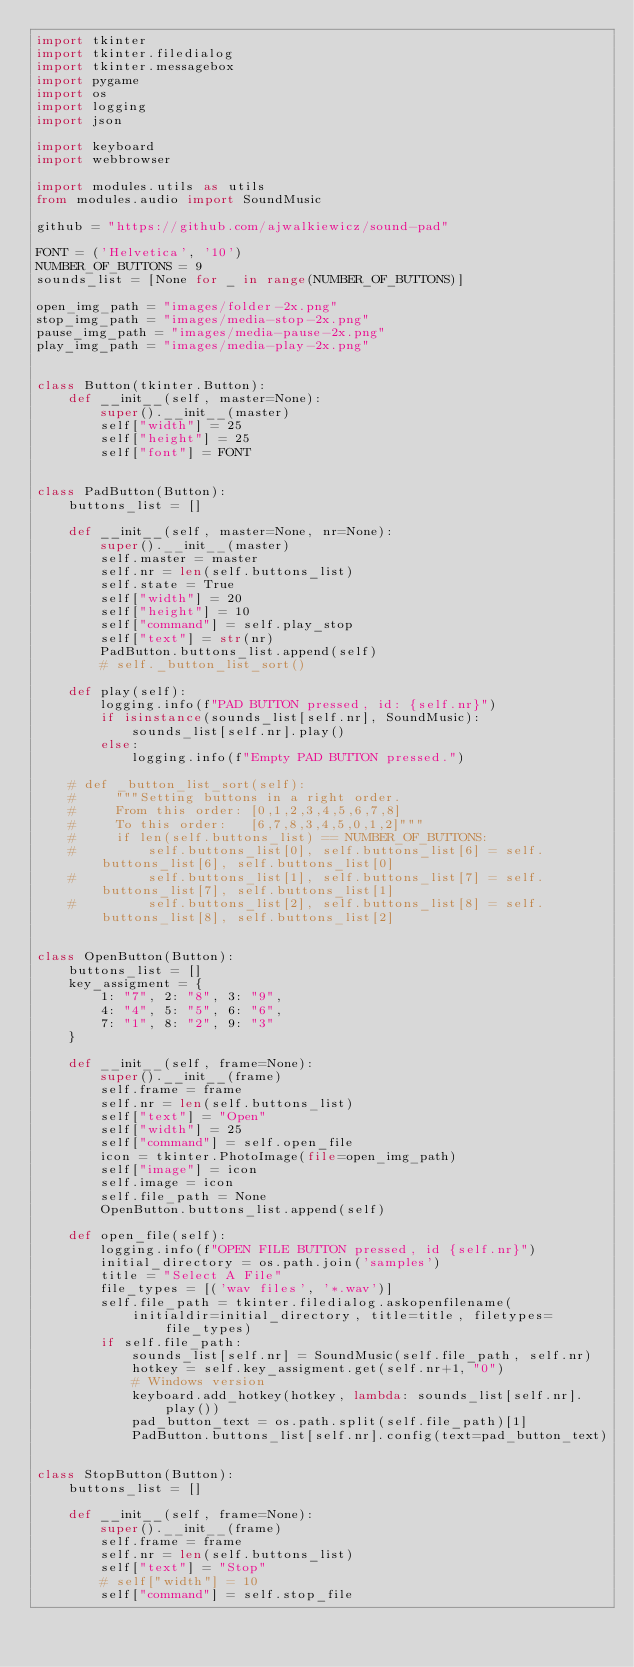<code> <loc_0><loc_0><loc_500><loc_500><_Python_>import tkinter
import tkinter.filedialog
import tkinter.messagebox
import pygame
import os
import logging
import json

import keyboard
import webbrowser

import modules.utils as utils
from modules.audio import SoundMusic

github = "https://github.com/ajwalkiewicz/sound-pad"

FONT = ('Helvetica', '10')
NUMBER_OF_BUTTONS = 9
sounds_list = [None for _ in range(NUMBER_OF_BUTTONS)]

open_img_path = "images/folder-2x.png"
stop_img_path = "images/media-stop-2x.png"
pause_img_path = "images/media-pause-2x.png"
play_img_path = "images/media-play-2x.png"


class Button(tkinter.Button):
    def __init__(self, master=None):
        super().__init__(master)
        self["width"] = 25
        self["height"] = 25
        self["font"] = FONT


class PadButton(Button):
    buttons_list = []

    def __init__(self, master=None, nr=None):
        super().__init__(master)
        self.master = master
        self.nr = len(self.buttons_list)
        self.state = True
        self["width"] = 20
        self["height"] = 10
        self["command"] = self.play_stop
        self["text"] = str(nr)
        PadButton.buttons_list.append(self)
        # self._button_list_sort()

    def play(self):
        logging.info(f"PAD BUTTON pressed, id: {self.nr}")
        if isinstance(sounds_list[self.nr], SoundMusic):
            sounds_list[self.nr].play()
        else:
            logging.info(f"Empty PAD BUTTON pressed.")

    # def _button_list_sort(self):
    #     """Setting buttons in a right order.
    #     From this order: [0,1,2,3,4,5,6,7,8]
    #     To this order:   [6,7,8,3,4,5,0,1,2]"""
    #     if len(self.buttons_list) == NUMBER_OF_BUTTONS:
    #         self.buttons_list[0], self.buttons_list[6] = self.buttons_list[6], self.buttons_list[0]
    #         self.buttons_list[1], self.buttons_list[7] = self.buttons_list[7], self.buttons_list[1]
    #         self.buttons_list[2], self.buttons_list[8] = self.buttons_list[8], self.buttons_list[2]


class OpenButton(Button):
    buttons_list = []
    key_assigment = {
        1: "7", 2: "8", 3: "9",
        4: "4", 5: "5", 6: "6",
        7: "1", 8: "2", 9: "3"
    }

    def __init__(self, frame=None):
        super().__init__(frame)
        self.frame = frame
        self.nr = len(self.buttons_list)
        self["text"] = "Open"
        self["width"] = 25
        self["command"] = self.open_file
        icon = tkinter.PhotoImage(file=open_img_path)
        self["image"] = icon
        self.image = icon
        self.file_path = None
        OpenButton.buttons_list.append(self)

    def open_file(self):
        logging.info(f"OPEN FILE BUTTON pressed, id {self.nr}")
        initial_directory = os.path.join('samples')
        title = "Select A File"
        file_types = [('wav files', '*.wav')]
        self.file_path = tkinter.filedialog.askopenfilename(
            initialdir=initial_directory, title=title, filetypes=file_types)
        if self.file_path:
            sounds_list[self.nr] = SoundMusic(self.file_path, self.nr)
            hotkey = self.key_assigment.get(self.nr+1, "0")
            # Windows version
            keyboard.add_hotkey(hotkey, lambda: sounds_list[self.nr].play())
            pad_button_text = os.path.split(self.file_path)[1]
            PadButton.buttons_list[self.nr].config(text=pad_button_text)


class StopButton(Button):
    buttons_list = []

    def __init__(self, frame=None):
        super().__init__(frame)
        self.frame = frame
        self.nr = len(self.buttons_list)
        self["text"] = "Stop"
        # self["width"] = 10
        self["command"] = self.stop_file</code> 